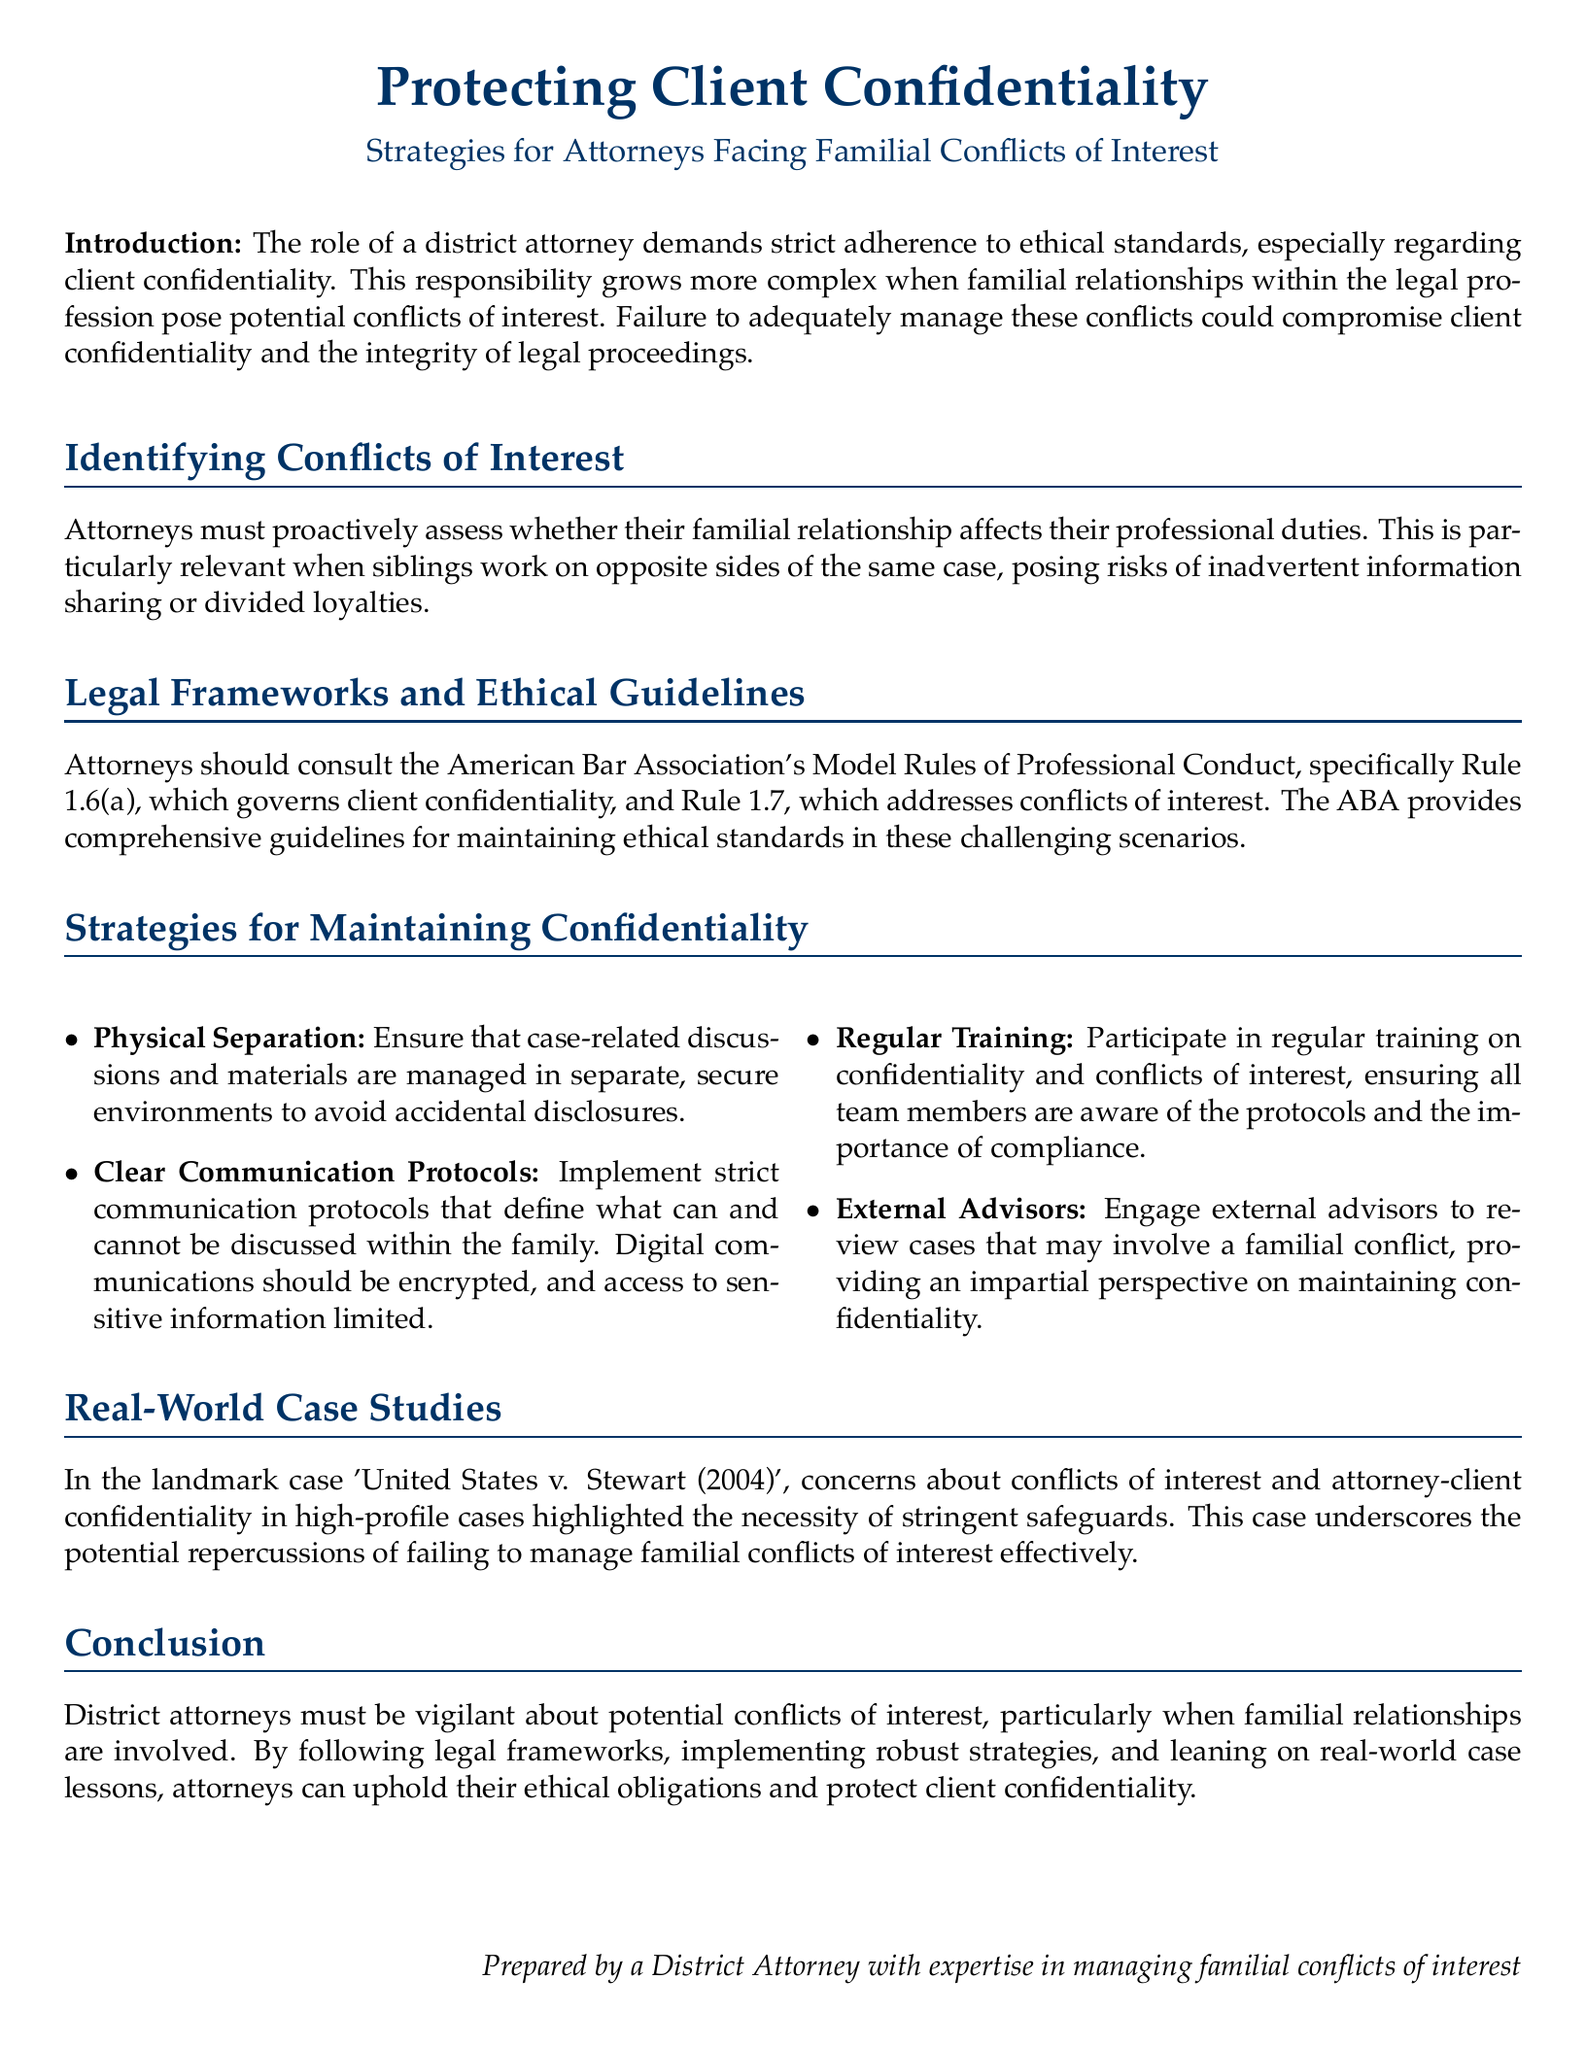what is the title of the document? The title is given in a central heading format at the beginning of the document, summarizing its focus on client confidentiality.
Answer: Protecting Client Confidentiality: Strategies for Attorneys Facing Familial Conflicts of Interest what does Rule 1.6(a) govern? This rule is referenced in the context of maintaining client confidentiality in the legal field.
Answer: client confidentiality what is one strategy for maintaining confidentiality? This information is listed under the strategies for attorneys facing familial conflicts, emphasizing proactive measures.
Answer: Physical Separation which landmark case is mentioned in the document? The case highlighted as an example underscores the repercussions of not managing familial conflicts effectively.
Answer: United States v. Stewart (2004) what do the initials ABA stand for? These initials represent an organization guiding legal ethical standards, which is frequently referenced in the document.
Answer: American Bar Association what is the primary concern addressed in the introduction? The introduction outlines the primary ethical responsibility related to client confidentiality, especially amidst familial conflicts.
Answer: client confidentiality how many strategies for maintaining confidentiality are listed? The document enumerates strategies under a multi-column format, indicating a total count.
Answer: four what should attorneys engage for impartial perspective? The document suggests a specific type of external support to aid in maintaining confidentiality amidst conflicts.
Answer: external advisors what type of professionals is the document aimed at? The document is directed toward those who uphold specific legal and ethical responsibilities within the legal field.
Answer: attorneys 